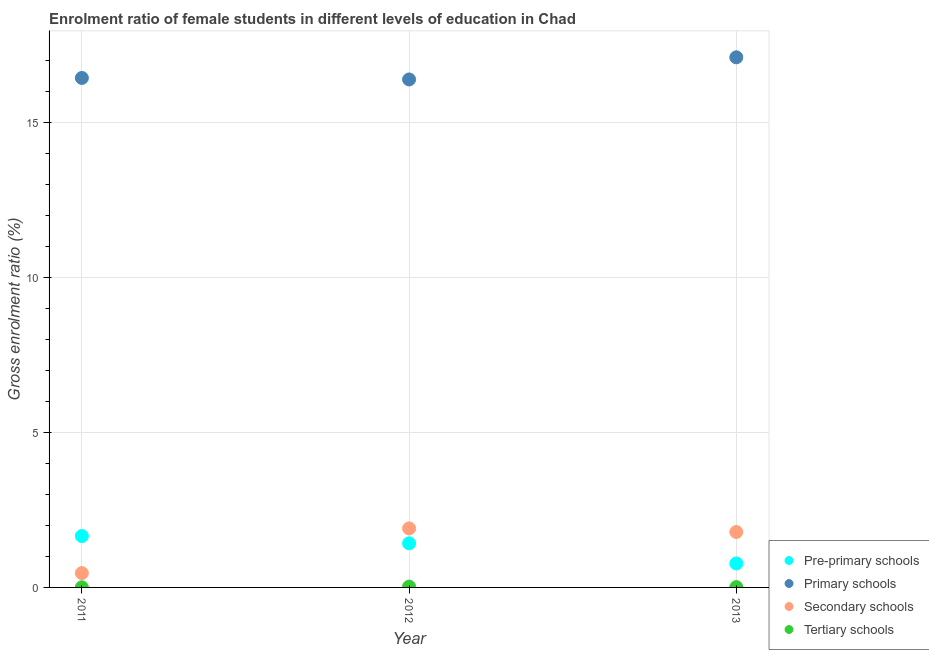How many different coloured dotlines are there?
Offer a very short reply. 4. What is the gross enrolment ratio(male) in primary schools in 2013?
Offer a very short reply. 17.12. Across all years, what is the maximum gross enrolment ratio(male) in pre-primary schools?
Offer a very short reply. 1.66. Across all years, what is the minimum gross enrolment ratio(male) in primary schools?
Provide a succinct answer. 16.4. What is the total gross enrolment ratio(male) in primary schools in the graph?
Offer a very short reply. 49.97. What is the difference between the gross enrolment ratio(male) in primary schools in 2011 and that in 2013?
Provide a succinct answer. -0.67. What is the difference between the gross enrolment ratio(male) in primary schools in 2013 and the gross enrolment ratio(male) in tertiary schools in 2012?
Offer a terse response. 17.09. What is the average gross enrolment ratio(male) in secondary schools per year?
Provide a succinct answer. 1.39. In the year 2012, what is the difference between the gross enrolment ratio(male) in primary schools and gross enrolment ratio(male) in tertiary schools?
Your answer should be compact. 16.38. In how many years, is the gross enrolment ratio(male) in pre-primary schools greater than 6 %?
Provide a short and direct response. 0. What is the ratio of the gross enrolment ratio(male) in tertiary schools in 2012 to that in 2013?
Give a very brief answer. 2.71. Is the gross enrolment ratio(male) in secondary schools in 2011 less than that in 2012?
Your answer should be compact. Yes. What is the difference between the highest and the second highest gross enrolment ratio(male) in pre-primary schools?
Provide a short and direct response. 0.24. What is the difference between the highest and the lowest gross enrolment ratio(male) in pre-primary schools?
Your answer should be very brief. 0.88. Is it the case that in every year, the sum of the gross enrolment ratio(male) in secondary schools and gross enrolment ratio(male) in primary schools is greater than the sum of gross enrolment ratio(male) in pre-primary schools and gross enrolment ratio(male) in tertiary schools?
Your answer should be very brief. Yes. Is it the case that in every year, the sum of the gross enrolment ratio(male) in pre-primary schools and gross enrolment ratio(male) in primary schools is greater than the gross enrolment ratio(male) in secondary schools?
Ensure brevity in your answer.  Yes. Does the gross enrolment ratio(male) in secondary schools monotonically increase over the years?
Your answer should be compact. No. Is the gross enrolment ratio(male) in pre-primary schools strictly greater than the gross enrolment ratio(male) in tertiary schools over the years?
Your answer should be compact. Yes. Is the gross enrolment ratio(male) in pre-primary schools strictly less than the gross enrolment ratio(male) in primary schools over the years?
Provide a short and direct response. Yes. How many years are there in the graph?
Keep it short and to the point. 3. Where does the legend appear in the graph?
Ensure brevity in your answer.  Bottom right. How many legend labels are there?
Keep it short and to the point. 4. What is the title of the graph?
Offer a very short reply. Enrolment ratio of female students in different levels of education in Chad. Does "Grants and Revenue" appear as one of the legend labels in the graph?
Give a very brief answer. No. What is the label or title of the X-axis?
Offer a very short reply. Year. What is the label or title of the Y-axis?
Provide a short and direct response. Gross enrolment ratio (%). What is the Gross enrolment ratio (%) in Pre-primary schools in 2011?
Your response must be concise. 1.66. What is the Gross enrolment ratio (%) of Primary schools in 2011?
Offer a very short reply. 16.45. What is the Gross enrolment ratio (%) in Secondary schools in 2011?
Provide a short and direct response. 0.46. What is the Gross enrolment ratio (%) in Tertiary schools in 2011?
Your answer should be compact. 0. What is the Gross enrolment ratio (%) of Pre-primary schools in 2012?
Give a very brief answer. 1.42. What is the Gross enrolment ratio (%) of Primary schools in 2012?
Offer a terse response. 16.4. What is the Gross enrolment ratio (%) of Secondary schools in 2012?
Keep it short and to the point. 1.91. What is the Gross enrolment ratio (%) of Tertiary schools in 2012?
Ensure brevity in your answer.  0.03. What is the Gross enrolment ratio (%) in Pre-primary schools in 2013?
Keep it short and to the point. 0.77. What is the Gross enrolment ratio (%) of Primary schools in 2013?
Ensure brevity in your answer.  17.12. What is the Gross enrolment ratio (%) in Secondary schools in 2013?
Ensure brevity in your answer.  1.79. What is the Gross enrolment ratio (%) of Tertiary schools in 2013?
Your answer should be very brief. 0.01. Across all years, what is the maximum Gross enrolment ratio (%) of Pre-primary schools?
Give a very brief answer. 1.66. Across all years, what is the maximum Gross enrolment ratio (%) in Primary schools?
Provide a short and direct response. 17.12. Across all years, what is the maximum Gross enrolment ratio (%) in Secondary schools?
Keep it short and to the point. 1.91. Across all years, what is the maximum Gross enrolment ratio (%) in Tertiary schools?
Provide a short and direct response. 0.03. Across all years, what is the minimum Gross enrolment ratio (%) of Pre-primary schools?
Your answer should be compact. 0.77. Across all years, what is the minimum Gross enrolment ratio (%) of Primary schools?
Give a very brief answer. 16.4. Across all years, what is the minimum Gross enrolment ratio (%) of Secondary schools?
Your answer should be very brief. 0.46. Across all years, what is the minimum Gross enrolment ratio (%) of Tertiary schools?
Your response must be concise. 0. What is the total Gross enrolment ratio (%) of Pre-primary schools in the graph?
Your answer should be very brief. 3.86. What is the total Gross enrolment ratio (%) in Primary schools in the graph?
Provide a short and direct response. 49.97. What is the total Gross enrolment ratio (%) of Secondary schools in the graph?
Your answer should be compact. 4.16. What is the total Gross enrolment ratio (%) of Tertiary schools in the graph?
Offer a terse response. 0.04. What is the difference between the Gross enrolment ratio (%) in Pre-primary schools in 2011 and that in 2012?
Ensure brevity in your answer.  0.24. What is the difference between the Gross enrolment ratio (%) of Primary schools in 2011 and that in 2012?
Offer a terse response. 0.05. What is the difference between the Gross enrolment ratio (%) of Secondary schools in 2011 and that in 2012?
Keep it short and to the point. -1.44. What is the difference between the Gross enrolment ratio (%) of Tertiary schools in 2011 and that in 2012?
Provide a succinct answer. -0.02. What is the difference between the Gross enrolment ratio (%) in Pre-primary schools in 2011 and that in 2013?
Provide a short and direct response. 0.88. What is the difference between the Gross enrolment ratio (%) of Primary schools in 2011 and that in 2013?
Make the answer very short. -0.67. What is the difference between the Gross enrolment ratio (%) in Secondary schools in 2011 and that in 2013?
Give a very brief answer. -1.33. What is the difference between the Gross enrolment ratio (%) of Tertiary schools in 2011 and that in 2013?
Give a very brief answer. -0.01. What is the difference between the Gross enrolment ratio (%) of Pre-primary schools in 2012 and that in 2013?
Make the answer very short. 0.65. What is the difference between the Gross enrolment ratio (%) in Primary schools in 2012 and that in 2013?
Your response must be concise. -0.71. What is the difference between the Gross enrolment ratio (%) of Secondary schools in 2012 and that in 2013?
Your answer should be very brief. 0.12. What is the difference between the Gross enrolment ratio (%) of Tertiary schools in 2012 and that in 2013?
Offer a very short reply. 0.02. What is the difference between the Gross enrolment ratio (%) in Pre-primary schools in 2011 and the Gross enrolment ratio (%) in Primary schools in 2012?
Make the answer very short. -14.74. What is the difference between the Gross enrolment ratio (%) in Pre-primary schools in 2011 and the Gross enrolment ratio (%) in Secondary schools in 2012?
Your response must be concise. -0.25. What is the difference between the Gross enrolment ratio (%) in Pre-primary schools in 2011 and the Gross enrolment ratio (%) in Tertiary schools in 2012?
Keep it short and to the point. 1.63. What is the difference between the Gross enrolment ratio (%) of Primary schools in 2011 and the Gross enrolment ratio (%) of Secondary schools in 2012?
Provide a short and direct response. 14.55. What is the difference between the Gross enrolment ratio (%) in Primary schools in 2011 and the Gross enrolment ratio (%) in Tertiary schools in 2012?
Offer a very short reply. 16.42. What is the difference between the Gross enrolment ratio (%) in Secondary schools in 2011 and the Gross enrolment ratio (%) in Tertiary schools in 2012?
Make the answer very short. 0.44. What is the difference between the Gross enrolment ratio (%) in Pre-primary schools in 2011 and the Gross enrolment ratio (%) in Primary schools in 2013?
Your answer should be compact. -15.46. What is the difference between the Gross enrolment ratio (%) in Pre-primary schools in 2011 and the Gross enrolment ratio (%) in Secondary schools in 2013?
Ensure brevity in your answer.  -0.13. What is the difference between the Gross enrolment ratio (%) of Pre-primary schools in 2011 and the Gross enrolment ratio (%) of Tertiary schools in 2013?
Provide a short and direct response. 1.65. What is the difference between the Gross enrolment ratio (%) of Primary schools in 2011 and the Gross enrolment ratio (%) of Secondary schools in 2013?
Give a very brief answer. 14.66. What is the difference between the Gross enrolment ratio (%) of Primary schools in 2011 and the Gross enrolment ratio (%) of Tertiary schools in 2013?
Your answer should be compact. 16.44. What is the difference between the Gross enrolment ratio (%) of Secondary schools in 2011 and the Gross enrolment ratio (%) of Tertiary schools in 2013?
Ensure brevity in your answer.  0.45. What is the difference between the Gross enrolment ratio (%) in Pre-primary schools in 2012 and the Gross enrolment ratio (%) in Primary schools in 2013?
Make the answer very short. -15.69. What is the difference between the Gross enrolment ratio (%) of Pre-primary schools in 2012 and the Gross enrolment ratio (%) of Secondary schools in 2013?
Your response must be concise. -0.37. What is the difference between the Gross enrolment ratio (%) of Pre-primary schools in 2012 and the Gross enrolment ratio (%) of Tertiary schools in 2013?
Keep it short and to the point. 1.41. What is the difference between the Gross enrolment ratio (%) of Primary schools in 2012 and the Gross enrolment ratio (%) of Secondary schools in 2013?
Your answer should be compact. 14.61. What is the difference between the Gross enrolment ratio (%) of Primary schools in 2012 and the Gross enrolment ratio (%) of Tertiary schools in 2013?
Ensure brevity in your answer.  16.39. What is the difference between the Gross enrolment ratio (%) of Secondary schools in 2012 and the Gross enrolment ratio (%) of Tertiary schools in 2013?
Ensure brevity in your answer.  1.9. What is the average Gross enrolment ratio (%) of Pre-primary schools per year?
Your answer should be compact. 1.29. What is the average Gross enrolment ratio (%) of Primary schools per year?
Keep it short and to the point. 16.66. What is the average Gross enrolment ratio (%) in Secondary schools per year?
Offer a very short reply. 1.39. What is the average Gross enrolment ratio (%) of Tertiary schools per year?
Your answer should be very brief. 0.01. In the year 2011, what is the difference between the Gross enrolment ratio (%) of Pre-primary schools and Gross enrolment ratio (%) of Primary schools?
Your response must be concise. -14.79. In the year 2011, what is the difference between the Gross enrolment ratio (%) in Pre-primary schools and Gross enrolment ratio (%) in Secondary schools?
Your answer should be very brief. 1.2. In the year 2011, what is the difference between the Gross enrolment ratio (%) of Pre-primary schools and Gross enrolment ratio (%) of Tertiary schools?
Provide a short and direct response. 1.66. In the year 2011, what is the difference between the Gross enrolment ratio (%) of Primary schools and Gross enrolment ratio (%) of Secondary schools?
Offer a very short reply. 15.99. In the year 2011, what is the difference between the Gross enrolment ratio (%) in Primary schools and Gross enrolment ratio (%) in Tertiary schools?
Ensure brevity in your answer.  16.45. In the year 2011, what is the difference between the Gross enrolment ratio (%) in Secondary schools and Gross enrolment ratio (%) in Tertiary schools?
Give a very brief answer. 0.46. In the year 2012, what is the difference between the Gross enrolment ratio (%) of Pre-primary schools and Gross enrolment ratio (%) of Primary schools?
Keep it short and to the point. -14.98. In the year 2012, what is the difference between the Gross enrolment ratio (%) of Pre-primary schools and Gross enrolment ratio (%) of Secondary schools?
Your answer should be compact. -0.48. In the year 2012, what is the difference between the Gross enrolment ratio (%) of Pre-primary schools and Gross enrolment ratio (%) of Tertiary schools?
Ensure brevity in your answer.  1.4. In the year 2012, what is the difference between the Gross enrolment ratio (%) of Primary schools and Gross enrolment ratio (%) of Secondary schools?
Your response must be concise. 14.5. In the year 2012, what is the difference between the Gross enrolment ratio (%) of Primary schools and Gross enrolment ratio (%) of Tertiary schools?
Ensure brevity in your answer.  16.38. In the year 2012, what is the difference between the Gross enrolment ratio (%) of Secondary schools and Gross enrolment ratio (%) of Tertiary schools?
Your response must be concise. 1.88. In the year 2013, what is the difference between the Gross enrolment ratio (%) in Pre-primary schools and Gross enrolment ratio (%) in Primary schools?
Offer a very short reply. -16.34. In the year 2013, what is the difference between the Gross enrolment ratio (%) of Pre-primary schools and Gross enrolment ratio (%) of Secondary schools?
Your answer should be compact. -1.02. In the year 2013, what is the difference between the Gross enrolment ratio (%) in Pre-primary schools and Gross enrolment ratio (%) in Tertiary schools?
Your answer should be very brief. 0.76. In the year 2013, what is the difference between the Gross enrolment ratio (%) of Primary schools and Gross enrolment ratio (%) of Secondary schools?
Your response must be concise. 15.33. In the year 2013, what is the difference between the Gross enrolment ratio (%) in Primary schools and Gross enrolment ratio (%) in Tertiary schools?
Your response must be concise. 17.11. In the year 2013, what is the difference between the Gross enrolment ratio (%) of Secondary schools and Gross enrolment ratio (%) of Tertiary schools?
Keep it short and to the point. 1.78. What is the ratio of the Gross enrolment ratio (%) of Pre-primary schools in 2011 to that in 2012?
Your response must be concise. 1.17. What is the ratio of the Gross enrolment ratio (%) in Primary schools in 2011 to that in 2012?
Your answer should be very brief. 1. What is the ratio of the Gross enrolment ratio (%) in Secondary schools in 2011 to that in 2012?
Keep it short and to the point. 0.24. What is the ratio of the Gross enrolment ratio (%) of Tertiary schools in 2011 to that in 2012?
Ensure brevity in your answer.  0.13. What is the ratio of the Gross enrolment ratio (%) of Pre-primary schools in 2011 to that in 2013?
Your response must be concise. 2.14. What is the ratio of the Gross enrolment ratio (%) of Primary schools in 2011 to that in 2013?
Your answer should be very brief. 0.96. What is the ratio of the Gross enrolment ratio (%) in Secondary schools in 2011 to that in 2013?
Make the answer very short. 0.26. What is the ratio of the Gross enrolment ratio (%) in Tertiary schools in 2011 to that in 2013?
Ensure brevity in your answer.  0.36. What is the ratio of the Gross enrolment ratio (%) of Pre-primary schools in 2012 to that in 2013?
Make the answer very short. 1.84. What is the ratio of the Gross enrolment ratio (%) of Secondary schools in 2012 to that in 2013?
Offer a very short reply. 1.06. What is the ratio of the Gross enrolment ratio (%) in Tertiary schools in 2012 to that in 2013?
Provide a short and direct response. 2.71. What is the difference between the highest and the second highest Gross enrolment ratio (%) of Pre-primary schools?
Ensure brevity in your answer.  0.24. What is the difference between the highest and the second highest Gross enrolment ratio (%) of Primary schools?
Your response must be concise. 0.67. What is the difference between the highest and the second highest Gross enrolment ratio (%) in Secondary schools?
Provide a short and direct response. 0.12. What is the difference between the highest and the second highest Gross enrolment ratio (%) of Tertiary schools?
Offer a very short reply. 0.02. What is the difference between the highest and the lowest Gross enrolment ratio (%) in Pre-primary schools?
Your answer should be compact. 0.88. What is the difference between the highest and the lowest Gross enrolment ratio (%) in Primary schools?
Offer a terse response. 0.71. What is the difference between the highest and the lowest Gross enrolment ratio (%) of Secondary schools?
Offer a terse response. 1.44. What is the difference between the highest and the lowest Gross enrolment ratio (%) of Tertiary schools?
Provide a succinct answer. 0.02. 